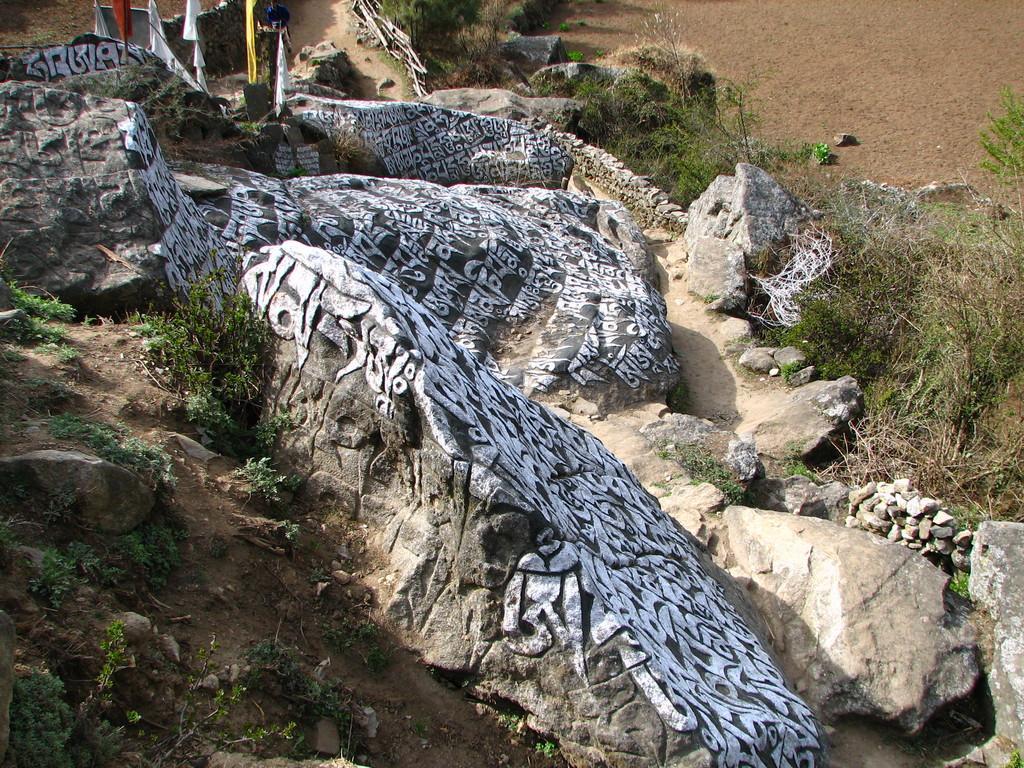Can you describe this image briefly? This image consists of rocks on which there is a text. At the bottom, there are small plants and grass on the ground. 